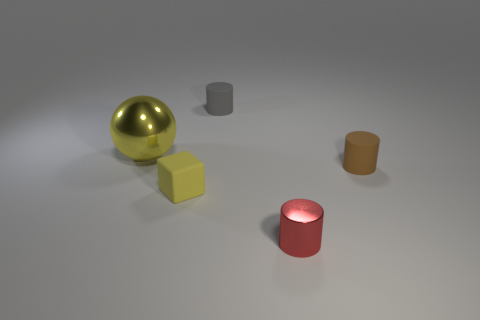What shape is the object that is the same color as the shiny sphere?
Provide a short and direct response. Cube. How many yellow balls are the same size as the gray rubber thing?
Provide a short and direct response. 0. Are there any matte things in front of the shiny thing that is to the right of the gray cylinder?
Your answer should be very brief. No. How many objects are either tiny red metallic objects or red matte things?
Provide a short and direct response. 1. What color is the rubber thing that is right of the small cylinder that is in front of the tiny thing that is on the left side of the gray rubber cylinder?
Give a very brief answer. Brown. Are there any other things of the same color as the rubber block?
Provide a short and direct response. Yes. Do the brown object and the yellow rubber cube have the same size?
Your response must be concise. Yes. How many objects are either metallic things that are to the left of the yellow matte cube or tiny things that are in front of the large yellow ball?
Make the answer very short. 4. The large object in front of the thing behind the big object is made of what material?
Offer a terse response. Metal. What number of other objects are the same material as the tiny gray thing?
Keep it short and to the point. 2. 